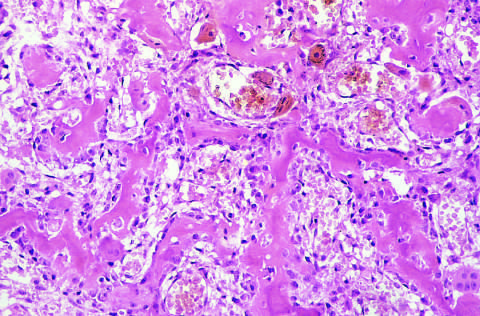s osteoid osteoma composed of haphazardly interconnecting trabeculae of woven bone that are rimmed by prominent osteoblasts?
Answer the question using a single word or phrase. Yes 